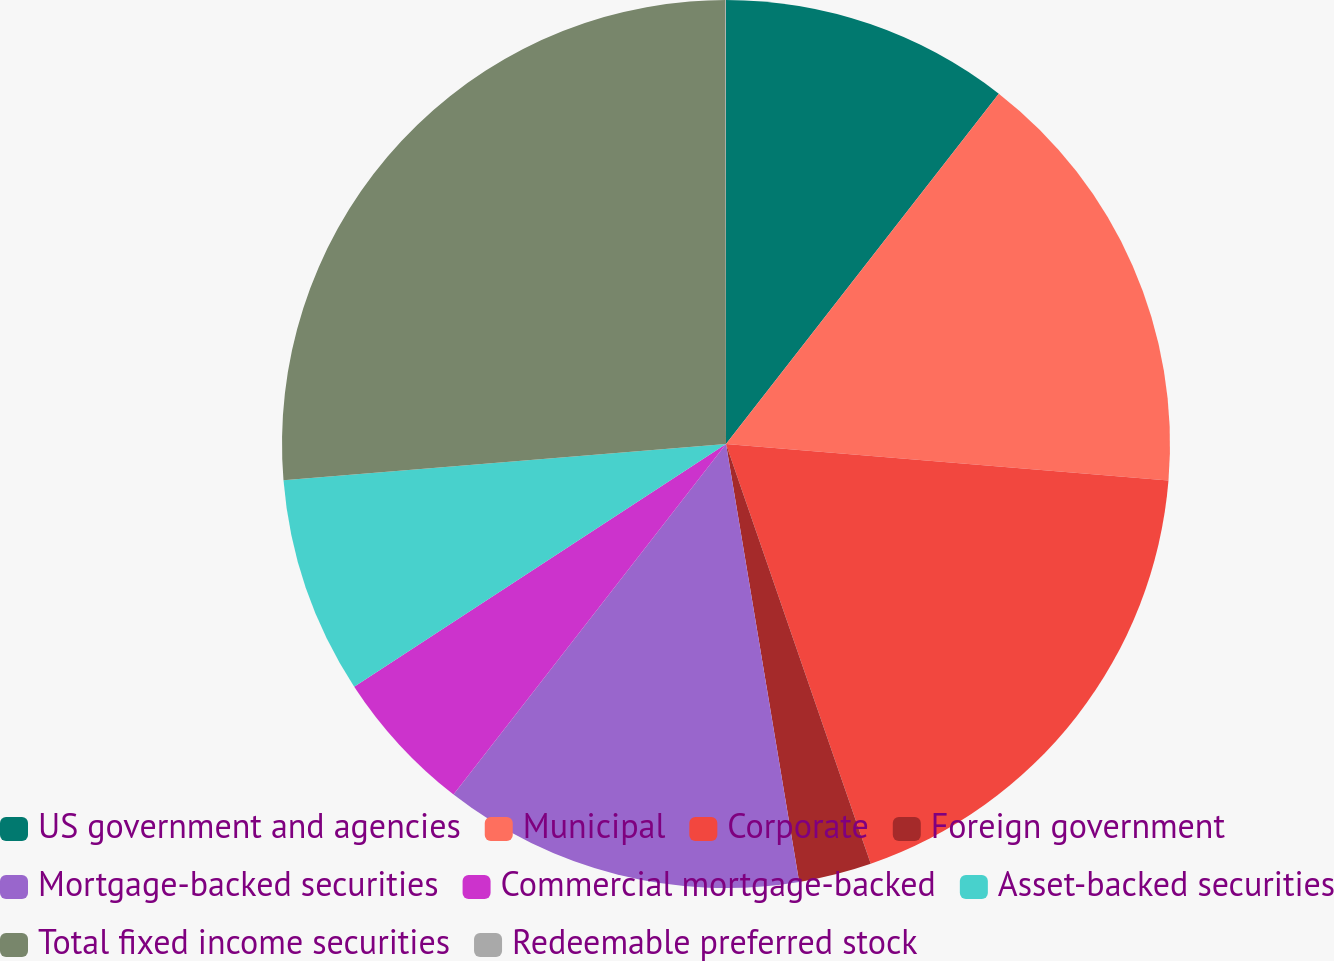Convert chart to OTSL. <chart><loc_0><loc_0><loc_500><loc_500><pie_chart><fcel>US government and agencies<fcel>Municipal<fcel>Corporate<fcel>Foreign government<fcel>Mortgage-backed securities<fcel>Commercial mortgage-backed<fcel>Asset-backed securities<fcel>Total fixed income securities<fcel>Redeemable preferred stock<nl><fcel>10.53%<fcel>15.78%<fcel>18.4%<fcel>2.65%<fcel>13.15%<fcel>5.28%<fcel>7.9%<fcel>26.28%<fcel>0.02%<nl></chart> 